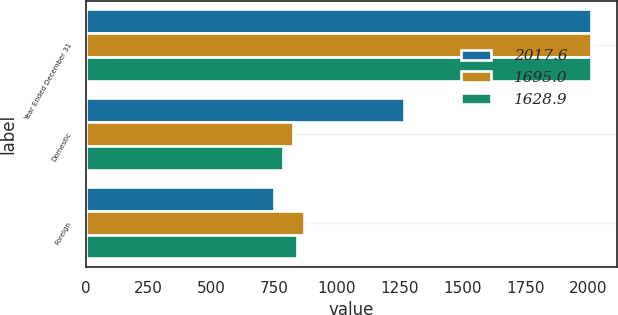Convert chart. <chart><loc_0><loc_0><loc_500><loc_500><stacked_bar_chart><ecel><fcel>Year Ended December 31<fcel>Domestic<fcel>Foreign<nl><fcel>2017.6<fcel>2014<fcel>1267.3<fcel>750.3<nl><fcel>1695<fcel>2013<fcel>827<fcel>868<nl><fcel>1628.9<fcel>2012<fcel>786.6<fcel>842.3<nl></chart> 